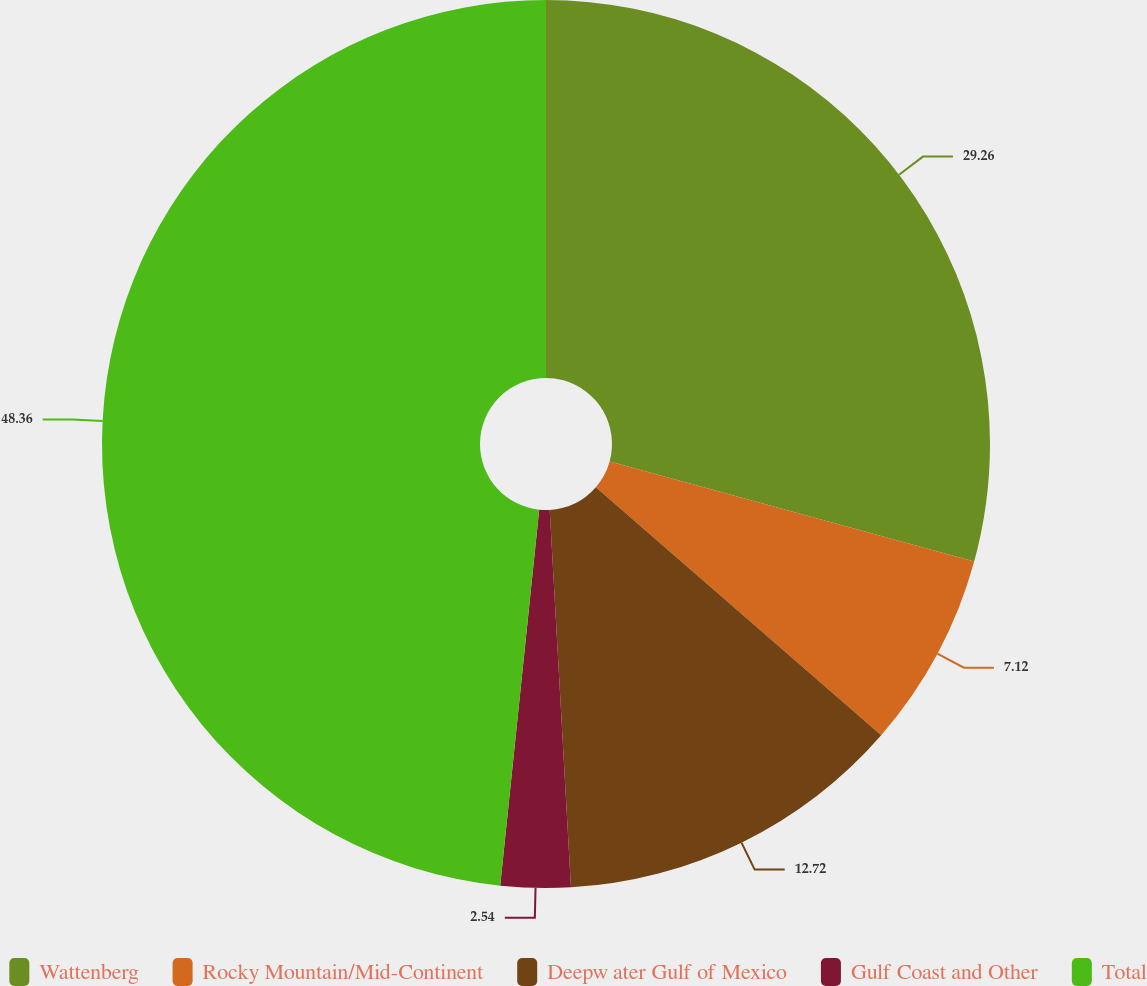Convert chart to OTSL. <chart><loc_0><loc_0><loc_500><loc_500><pie_chart><fcel>Wattenberg<fcel>Rocky Mountain/Mid-Continent<fcel>Deepw ater Gulf of Mexico<fcel>Gulf Coast and Other<fcel>Total<nl><fcel>29.26%<fcel>7.12%<fcel>12.72%<fcel>2.54%<fcel>48.35%<nl></chart> 